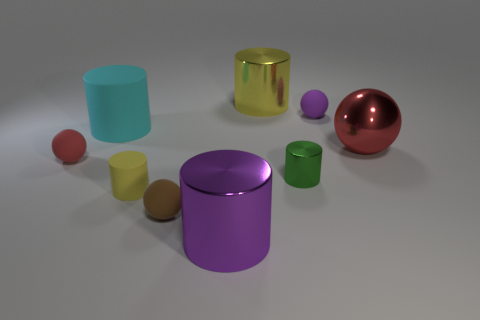Subtract all yellow metal cylinders. How many cylinders are left? 4 Subtract all cylinders. How many objects are left? 4 Subtract all yellow cylinders. How many cylinders are left? 3 Add 1 small yellow metal spheres. How many objects exist? 10 Add 9 tiny brown balls. How many tiny brown balls are left? 10 Add 8 large red matte objects. How many large red matte objects exist? 8 Subtract 1 green cylinders. How many objects are left? 8 Subtract 1 spheres. How many spheres are left? 3 Subtract all green balls. Subtract all gray cylinders. How many balls are left? 4 Subtract all red cylinders. How many blue balls are left? 0 